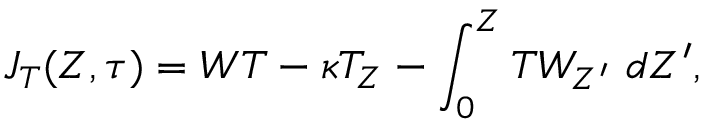<formula> <loc_0><loc_0><loc_500><loc_500>J _ { T } ( Z , \tau ) = W T - \kappa T _ { Z } - \int _ { 0 } ^ { Z } T W _ { Z ^ { \prime } } \ d Z ^ { \prime } ,</formula> 